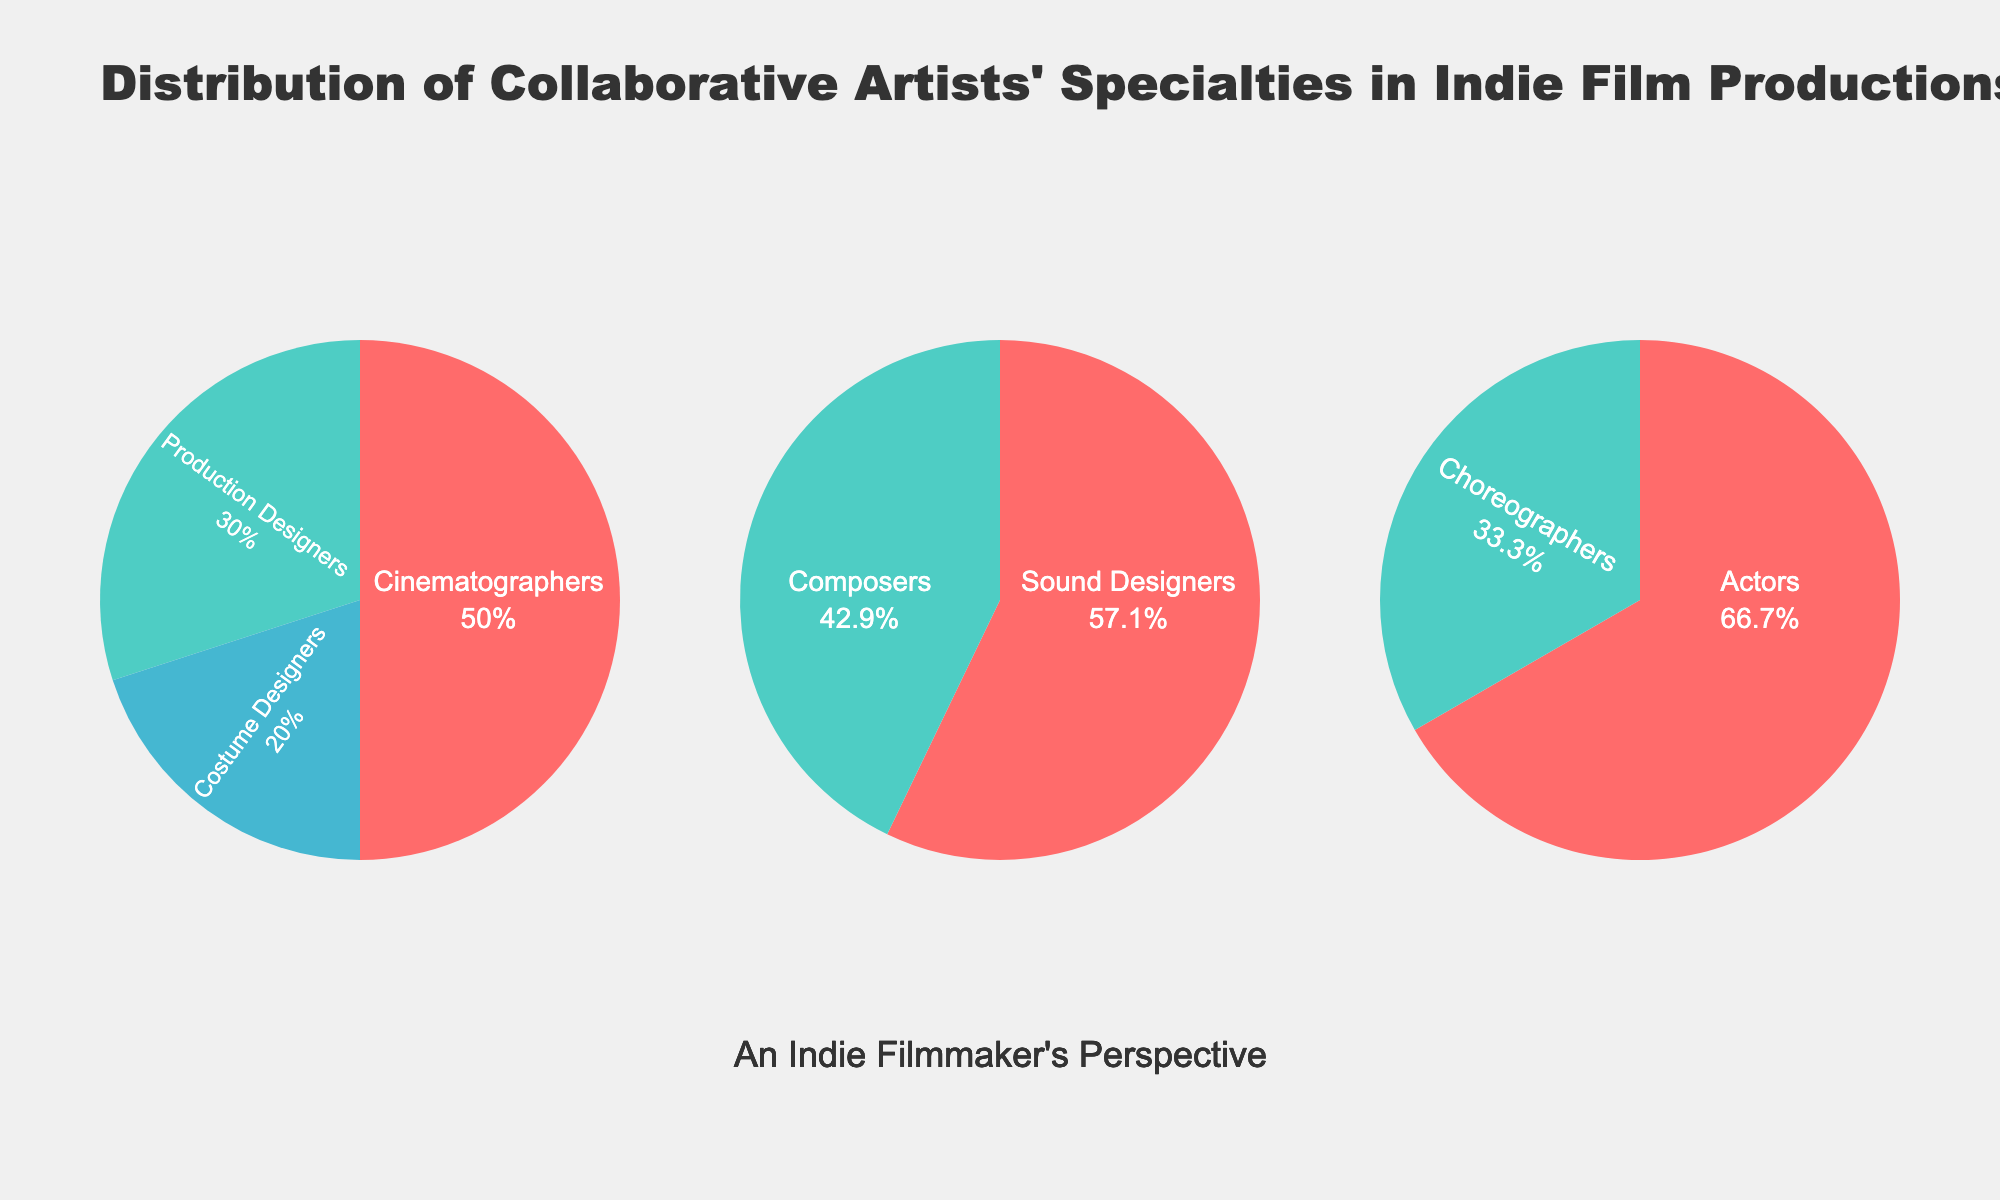What is the total percentage of visual artists in the indie film productions? Add the percentages of Cinematographers, Production Designers, and Costume Designers: 25% + 15% + 10% = 50%
Answer: 50% What type of artists are the most represented within the audio category? The percentages of Sound Designers and Composers within the audio category are 20% and 15%. Sound Designers have the highest percentage.
Answer: Sound Designers Which category has the fewest specialties? The categories are Visual, Audio, and Performance. Visual and Audio each have 3 specialties, while Performance has 2.
Answer: Performance How much greater is the percentage of Sound Designers compared to Choreographers? Sound Designers have 20% and Choreographers have 5%. The difference is 20% - 5% = 15%.
Answer: 15% What specialty represents the lowest percentage in the figure? Among all specialties, Choreographers have the lowest percentage, which is 5%.
Answer: Choreographers Which category depicts the most balanced distribution of specialties? By comparing the percentages, Audio (Sound Designers: 20%, Composers: 15%) seems most balanced as the percentages are closest to each other.
Answer: Audio Sum up the percentages of all specialties in the Performance category. Add the percentages of Actors and Choreographers: 10% + 5% = 15%
Answer: 15% Find the difference in percentage between Cinematographers and Composers. Cinematographers have 25%, and Composers have 15%. The difference is 25% - 15% = 10%.
Answer: 10% What is the total percentage of Performance and Audio categories combined? The Performance category is 10% + 5% = 15%. The Audio category is 20% + 15% = 35%. The total combined percentage is 15% + 35% = 50%.
Answer: 50% Which category has the highest single specialty percentage and what is it? Cinematographers in the Visual category have the highest single percentage, which is 25%.
Answer: Cinematographers, 25% 